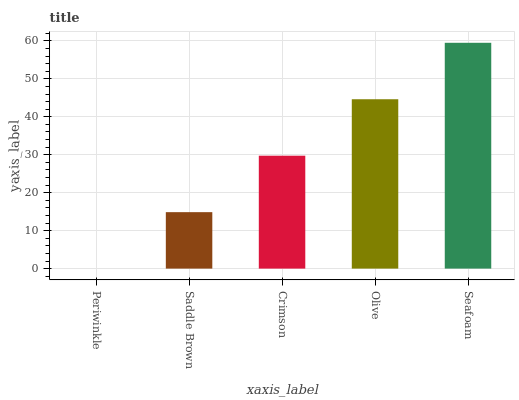Is Periwinkle the minimum?
Answer yes or no. Yes. Is Seafoam the maximum?
Answer yes or no. Yes. Is Saddle Brown the minimum?
Answer yes or no. No. Is Saddle Brown the maximum?
Answer yes or no. No. Is Saddle Brown greater than Periwinkle?
Answer yes or no. Yes. Is Periwinkle less than Saddle Brown?
Answer yes or no. Yes. Is Periwinkle greater than Saddle Brown?
Answer yes or no. No. Is Saddle Brown less than Periwinkle?
Answer yes or no. No. Is Crimson the high median?
Answer yes or no. Yes. Is Crimson the low median?
Answer yes or no. Yes. Is Olive the high median?
Answer yes or no. No. Is Seafoam the low median?
Answer yes or no. No. 